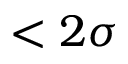<formula> <loc_0><loc_0><loc_500><loc_500>< 2 \sigma</formula> 